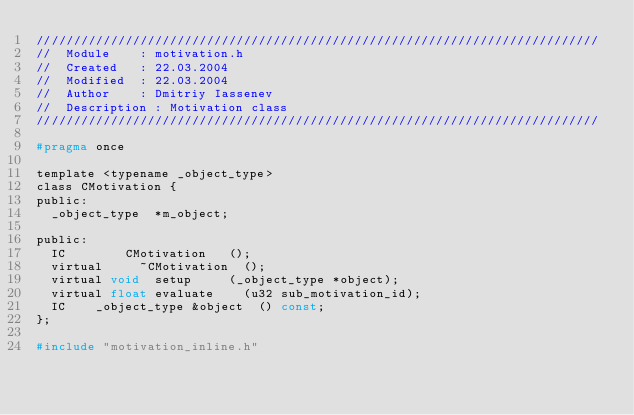Convert code to text. <code><loc_0><loc_0><loc_500><loc_500><_C_>////////////////////////////////////////////////////////////////////////////
//	Module 		: motivation.h
//	Created 	: 22.03.2004
//  Modified 	: 22.03.2004
//	Author		: Dmitriy Iassenev
//	Description : Motivation class
////////////////////////////////////////////////////////////////////////////

#pragma once

template <typename _object_type>
class CMotivation {
public:
	_object_type	*m_object;

public:
	IC				CMotivation		();
	virtual			~CMotivation	();
	virtual void	setup			(_object_type *object);
	virtual float	evaluate		(u32 sub_motivation_id);
	IC		_object_type &object	() const;
};

#include "motivation_inline.h"</code> 